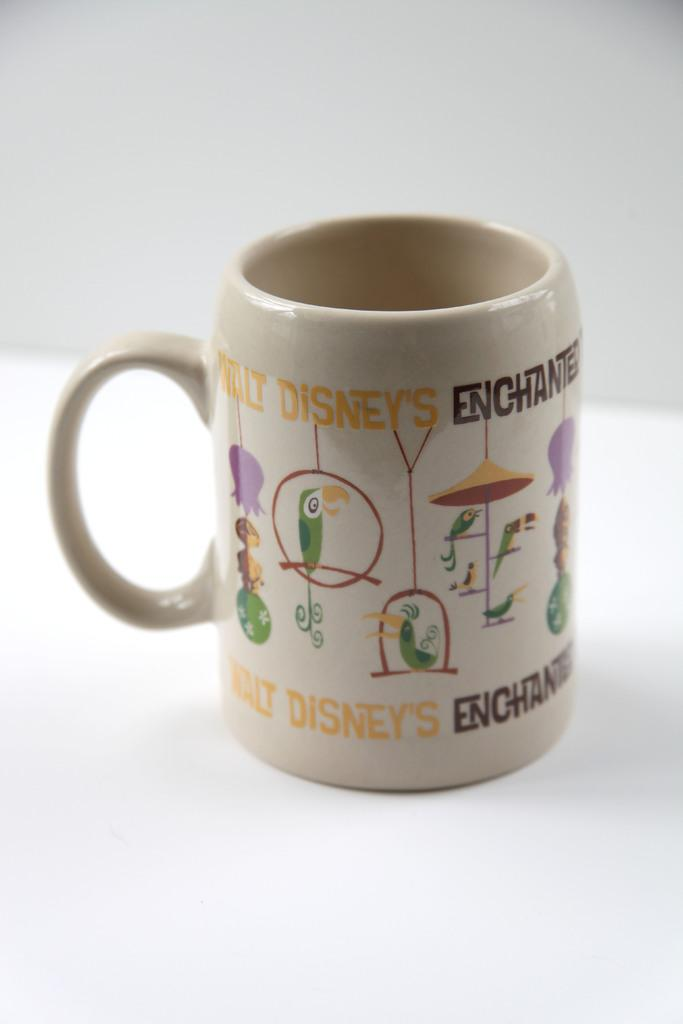<image>
Share a concise interpretation of the image provided. a cup with Walt Disney written on it 